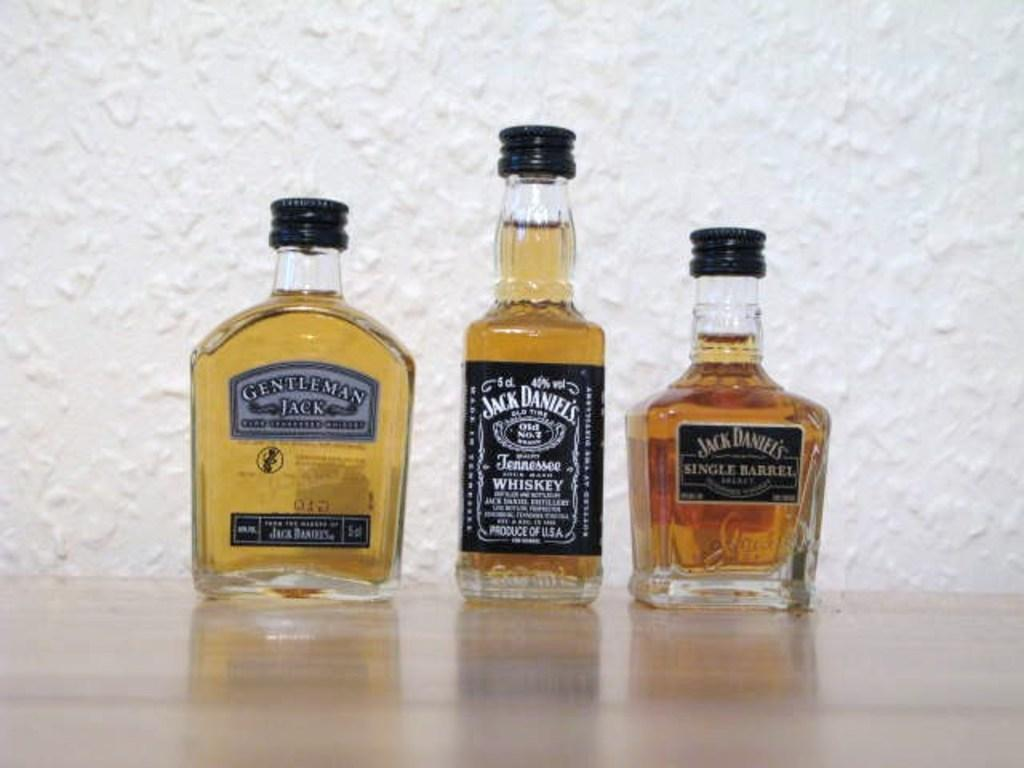<image>
Give a short and clear explanation of the subsequent image. Three different Jack bottles sit next to each other on a table 